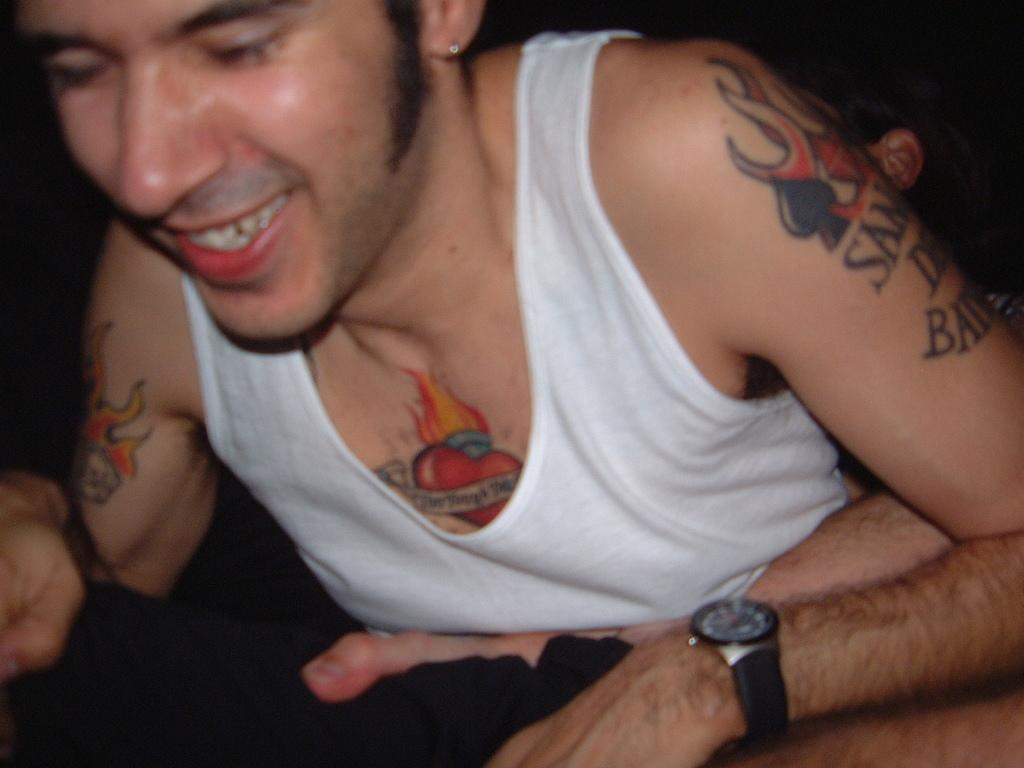Who is the main subject in the image? There is a man in the image. What is the man wearing in the image? The man is wearing a vest. Can you describe any other features of the man's appearance? The man has many tattoos on his body. What is the man's facial expression in the image? The man is smiling. What type of books can be seen on the man's tattoos in the image? There are no books visible on the man's tattoos in the image. 